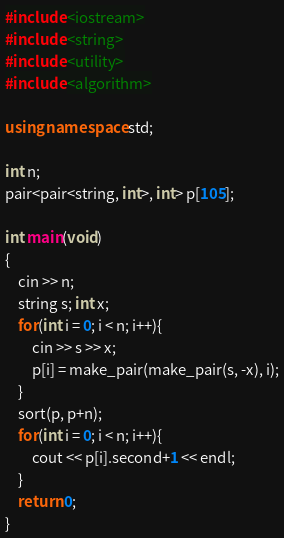<code> <loc_0><loc_0><loc_500><loc_500><_C++_>#include <iostream>
#include <string>
#include <utility>
#include <algorithm>

using namespace std;

int n;
pair<pair<string, int>, int> p[105];

int main(void)
{
	cin >> n;
	string s; int x;
	for(int i = 0; i < n; i++){
		cin >> s >> x;
		p[i] = make_pair(make_pair(s, -x), i);
	}
	sort(p, p+n);
	for(int i = 0; i < n; i++){
		cout << p[i].second+1 << endl;
	}
	return 0;
}</code> 